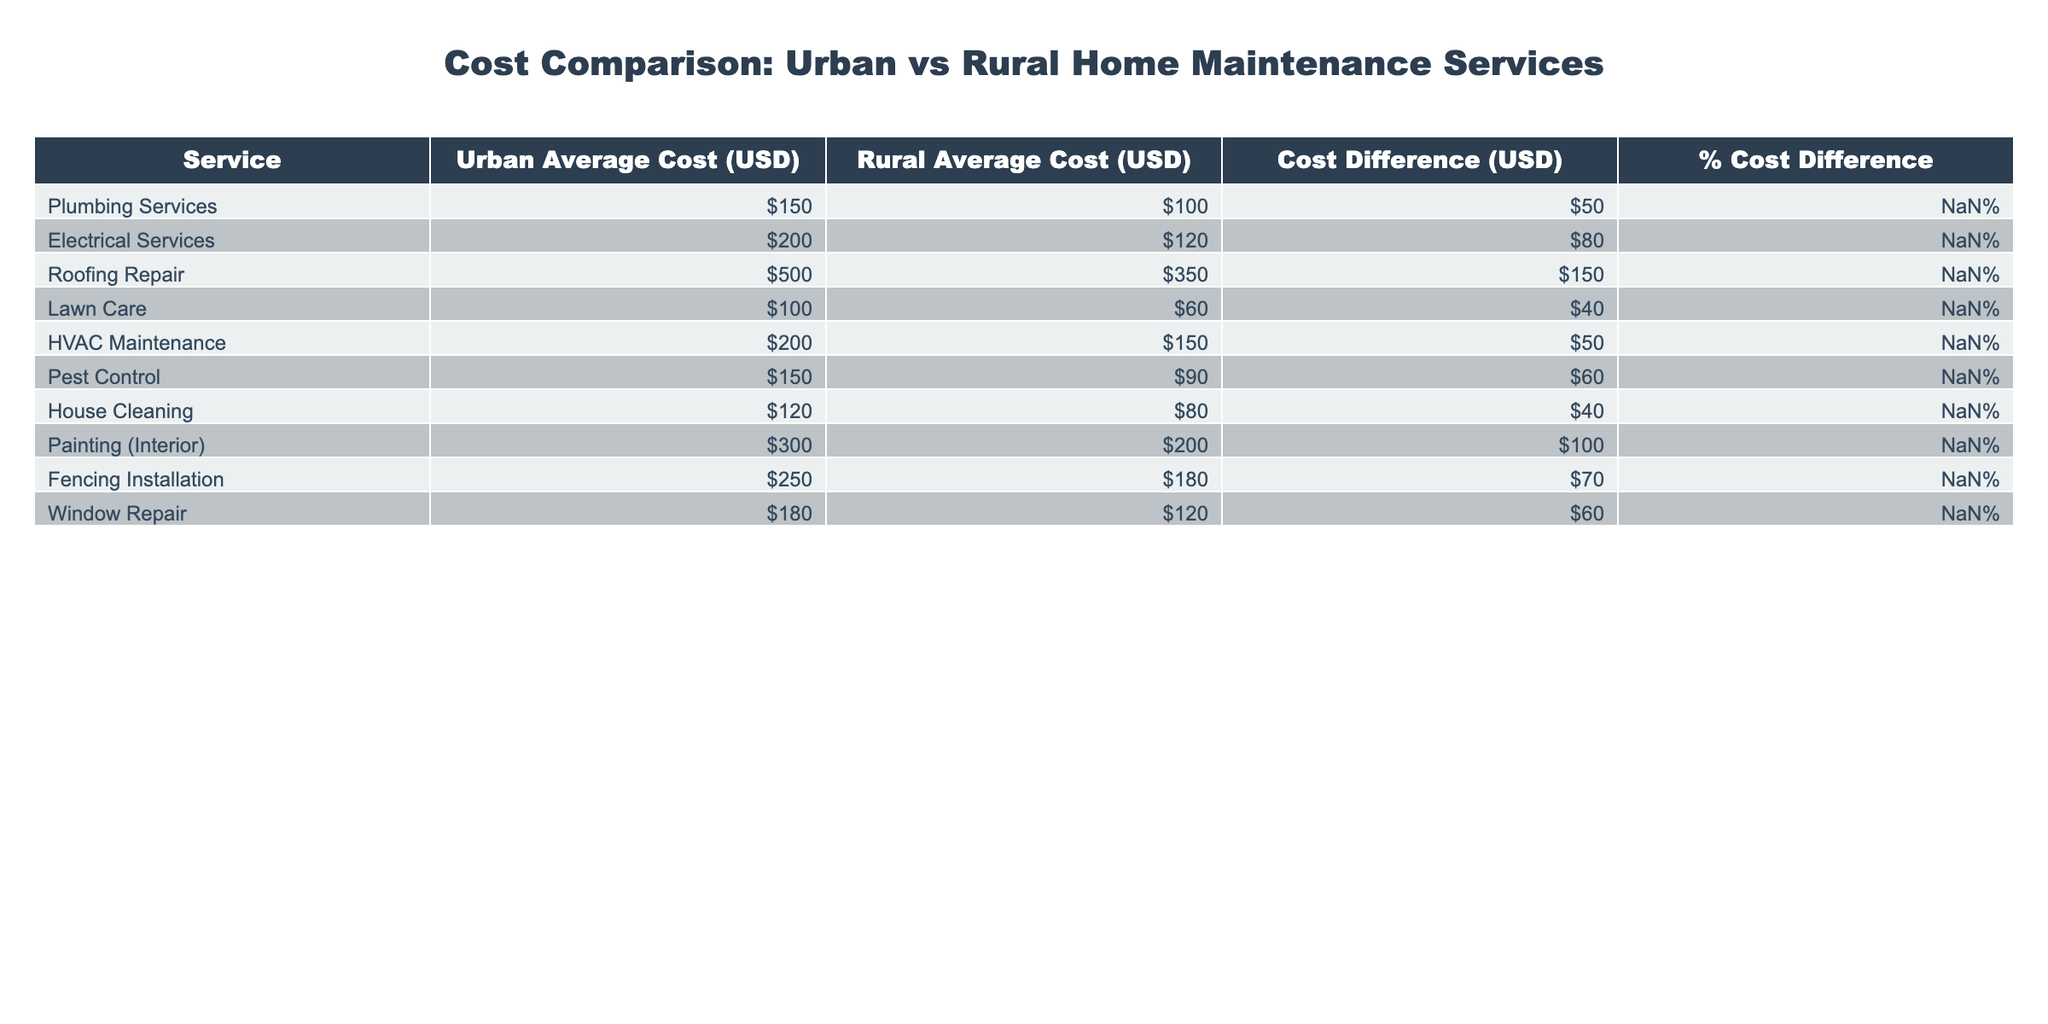What is the cost of plumbing services in urban areas? The table shows the cost for plumbing services in urban areas, which is listed as 150 USD.
Answer: 150 USD Which service has the highest cost difference between urban and rural areas? By comparing the "Cost Difference" column, the highest value is associated with electrical services, showing a difference of 80 USD.
Answer: Electrical services Is lawn care cheaper in rural areas compared to urban areas? The table lists lawn care costs at 60 USD in rural areas and 100 USD in urban areas, indicating that it is indeed cheaper in rural areas.
Answer: Yes What is the average cost of HVAC maintenance services in both areas? The urban average cost is 200 USD and the rural average cost is 150 USD. To find the average: (200 + 150) / 2 = 175 USD.
Answer: 175 USD If a homeowner is considering painting their interior, how much more would it cost in urban areas compared to rural areas? The cost for painting (interior) is 300 USD in urban areas and 200 USD in rural areas. The difference is calculated as 300 - 200 = 100 USD.
Answer: 100 USD Which services have a cost difference greater than 50 USD? Looking at the "Cost Difference" column, the services with differences greater than 50 USD are electrical services (80 USD), roofing repair (150 USD), lawn care (40 USD), pest control (60 USD), and painting (100 USD).
Answer: Electrical services, Roofing repair, Pest control, Painting What percentage difference in cost is noted for HVAC maintenance services? The table shows that HVAC maintenance services have a percentage difference of 25.00%.
Answer: 25.00% Are there any services that have a 40% cost difference? By checking the "% Cost Difference" column, pest control and lawn care both have a 40.00% cost difference, making this statement true.
Answer: Yes What is the total cost of plumbing and electrical services in urban areas? The urban costs for plumbing and electrical services are 150 USD and 200 USD respectively. So, the total is 150 + 200 = 350 USD.
Answer: 350 USD 